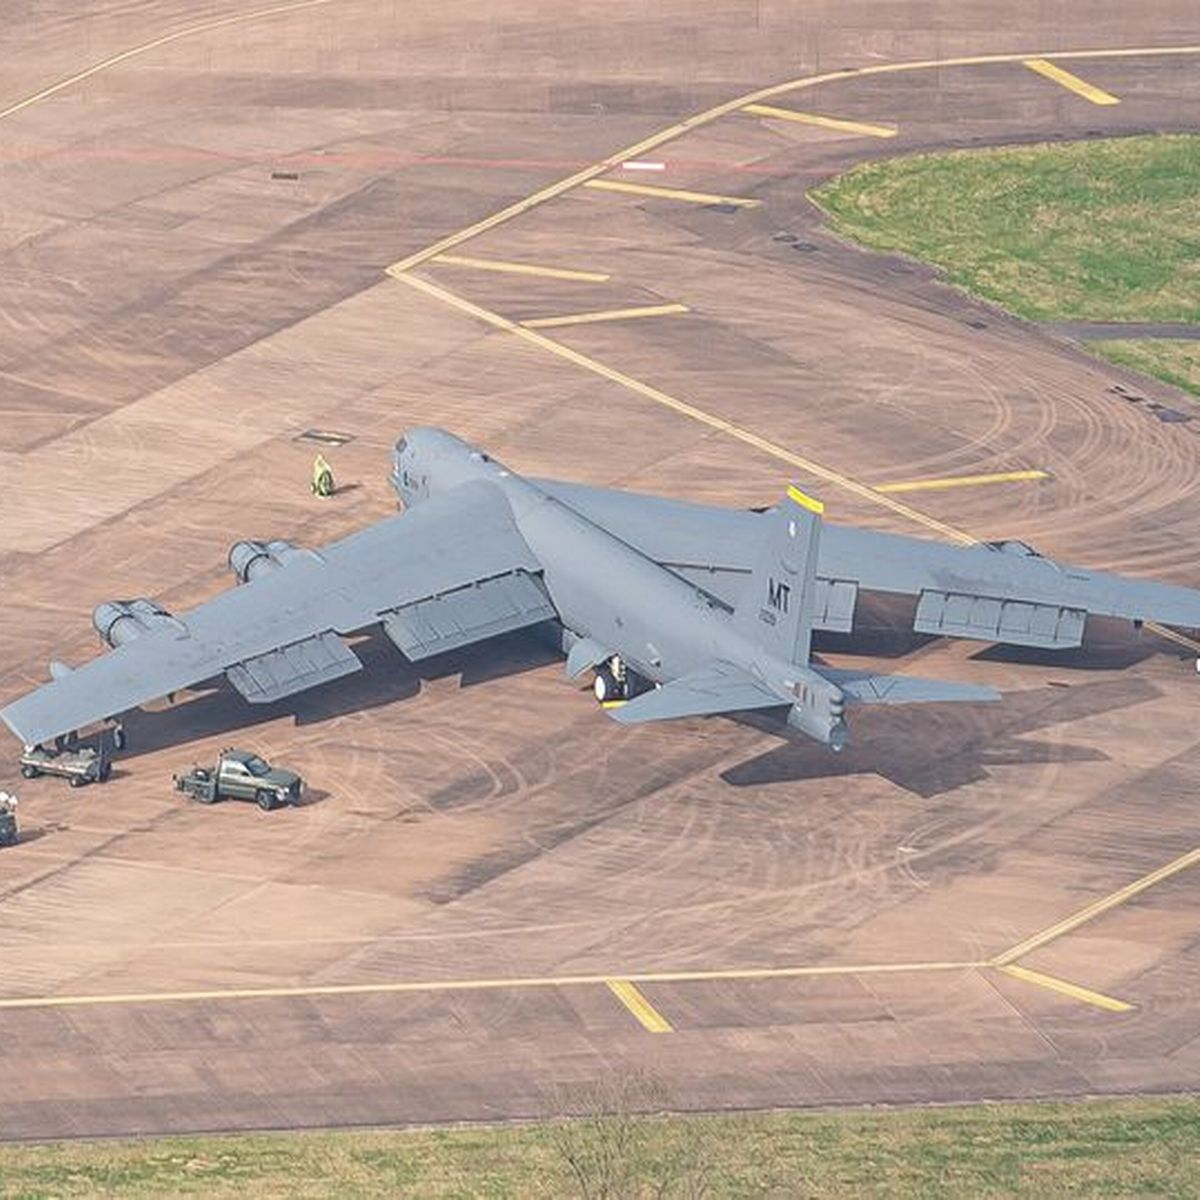Can you tell me about the surroundings of the plane? The aeroplane is on a well-maintained tarmac with clearly marked lines and signage. There are ground service vehicles nearby, indicative of support and maintenance activities. A single person is visible, likely a ground crew member, adhering to safety protocols in the vicinity of the aircraft. What kind of activities do you think are taking place around the plane? Considering the presence of support vehicles and the ground crew member, it's likely that the aircraft is undergoing routine pre-flight checks or post-flight maintenance. These activities can include refueling, inspection, and loading or unloading of cargo or equipment. 